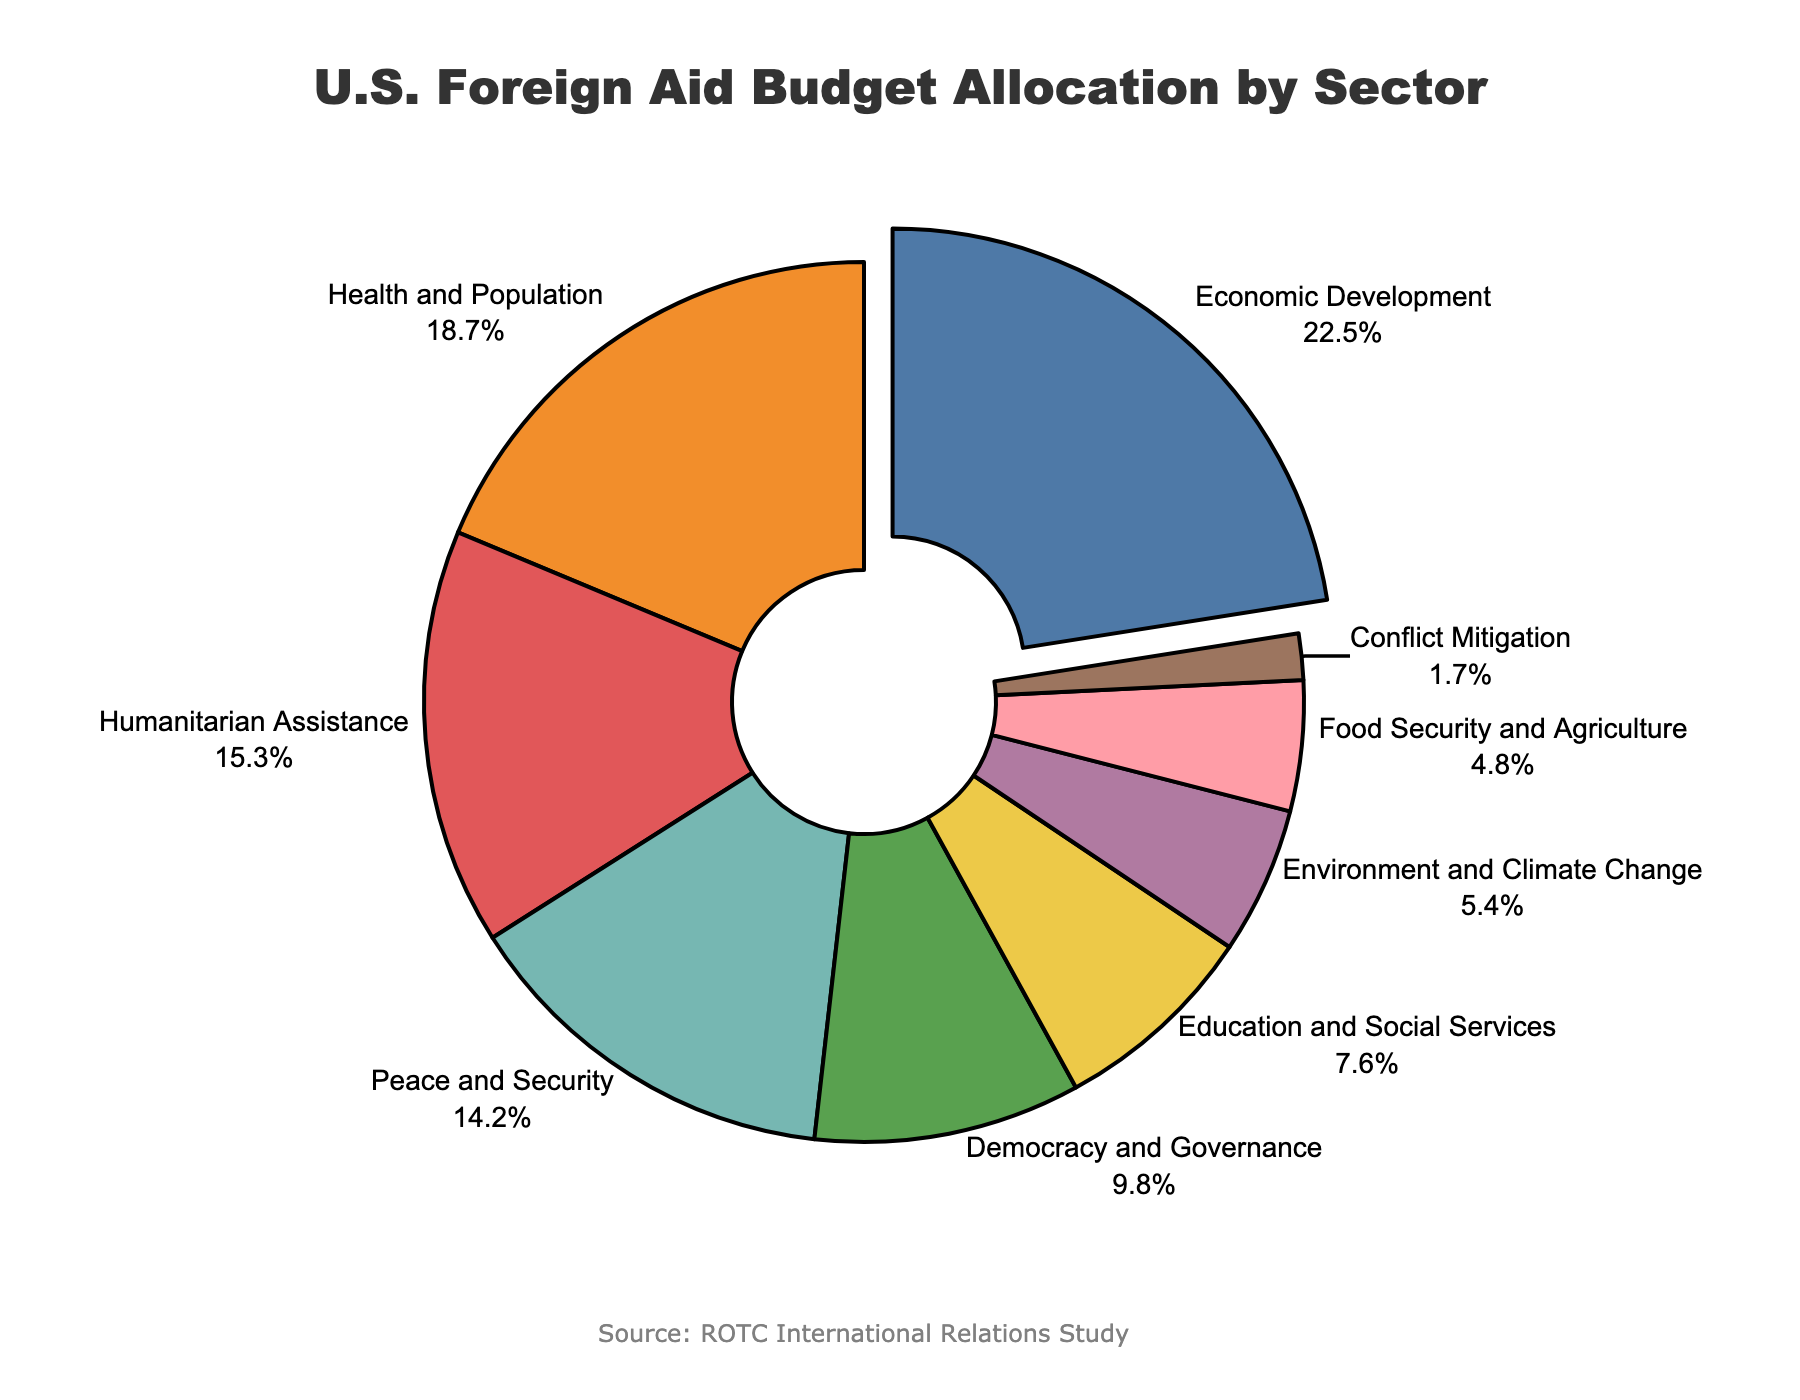what sector receives the highest percentage of the U.S. foreign aid budget? The pie chart shows that the sector with the largest slice is Economic Development, highlighted by a pull effect.
Answer: Economic Development which sectors have a combined allocation greater than 30%? Adding the percentages for the highest sectors: Economic Development (22.5%) and Health and Population (18.7%) gives a total of 41.2%, which is greater than 30%.
Answer: Economic Development and Health and Population what is the total percentage allocated to Health and Population combined with Humanitarian Assistance? Adding the percentages for Health and Population (18.7%) and Humanitarian Assistance (15.3%), we get 34.0%.
Answer: 34.0% compare the percentage allocated to Peace and Security with Education and Social Services. The chart shows Peace and Security at 14.2% and Education and Social Services at 7.6%. Peace and Security has almost double the percentage.
Answer: Peace and Security is higher what is the difference in percentage between the sectors with the highest and lowest allocations? The sector with the highest allocation is Economic Development at 22.5%, and the sector with the lowest allocation is Conflict Mitigation at 1.7%. The difference is 22.5% - 1.7% = 20.8%.
Answer: 20.8% which sector is represented by the green color on the pie chart? By referring to the color scheme used, the green slice represents the Democracy and Governance sector.
Answer: Democracy and Governance how does the percentage for Environment and Climate Change compare to that for Food Security and Agriculture? Environment and Climate Change has a percentage of 5.4%, while Food Security and Agriculture has 4.8%. The former is slightly higher.
Answer: Environment and Climate Change is higher what is the combined percentage of the last three sectors? Adding the percentages of Environment and Climate Change (5.4%), Food Security and Agriculture (4.8%), and Conflict Mitigation (1.7%), we get 11.9%.
Answer: 11.9% if Health and Population’s allocation was increased by 5%, what would the new total for this sector be? Adding 5% to Health and Population's current allocation of 18.7%, the new total would be 18.7% + 5% = 23.7%.
Answer: 23.7% which sectors have an allocation less than 10%? The sectors with an allocation less than 10% are Democracy and Governance (9.8%), Education and Social Services (7.6%), Environment and Climate Change (5.4%), Food Security and Agriculture (4.8%), and Conflict Mitigation (1.7%).
Answer: Democracy and Governance, Education and Social Services, Environment and Climate Change, Food Security and Agriculture, Conflict Mitigation 